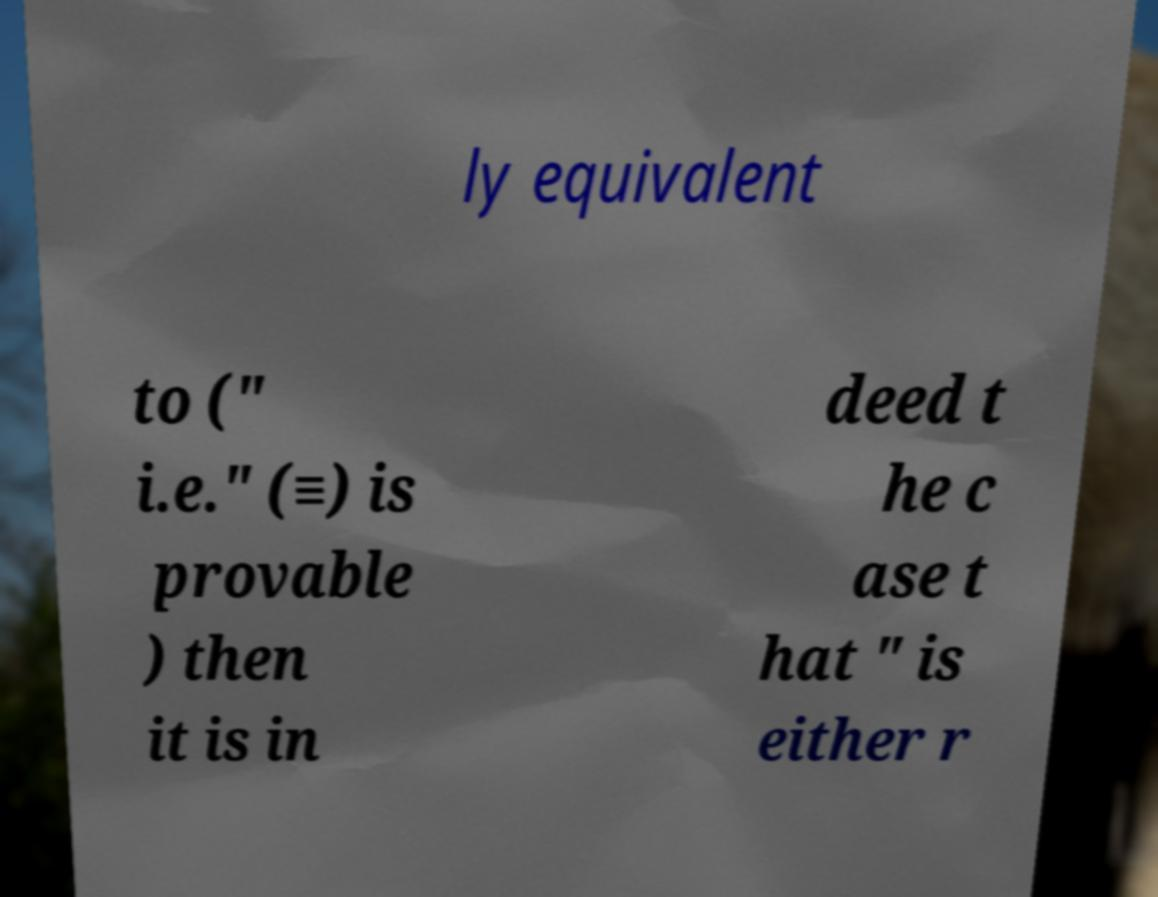What messages or text are displayed in this image? I need them in a readable, typed format. ly equivalent to (" i.e." (≡) is provable ) then it is in deed t he c ase t hat " is either r 